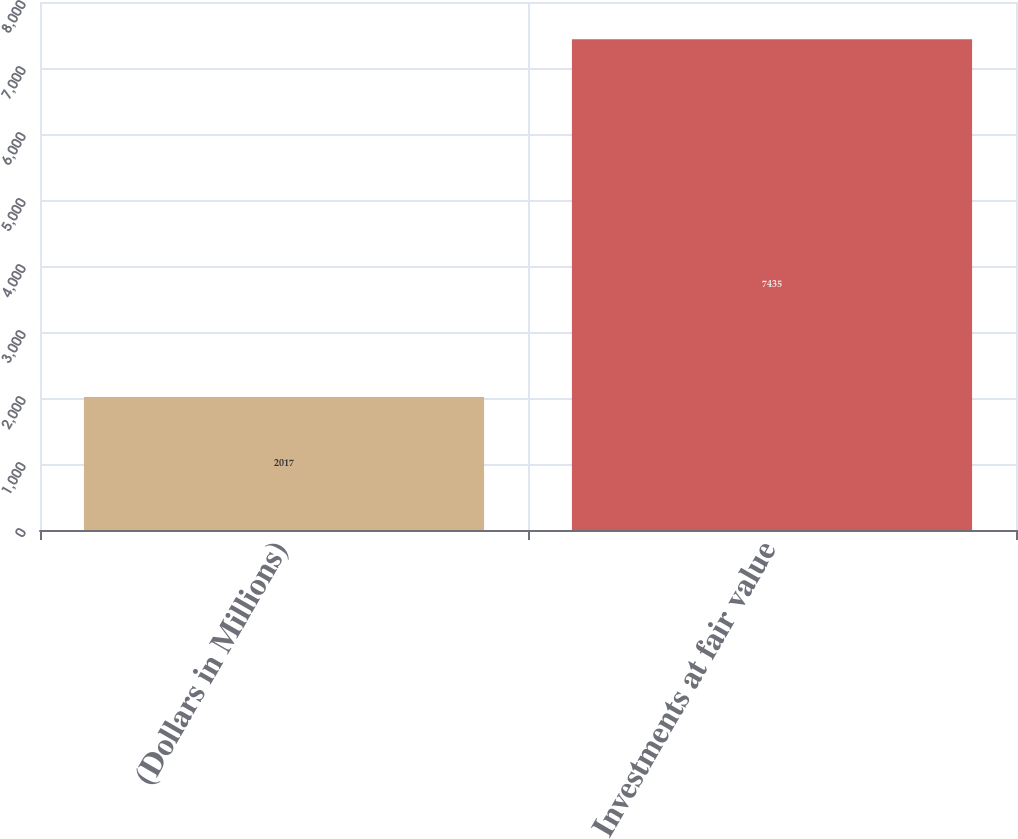<chart> <loc_0><loc_0><loc_500><loc_500><bar_chart><fcel>(Dollars in Millions)<fcel>Investments at fair value<nl><fcel>2017<fcel>7435<nl></chart> 